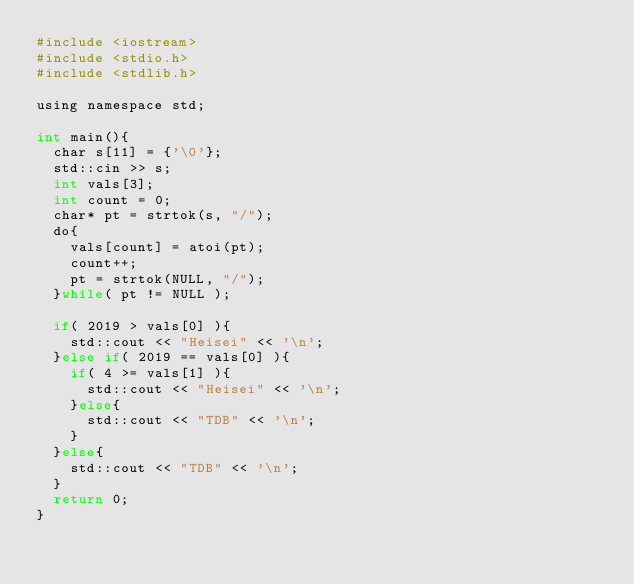<code> <loc_0><loc_0><loc_500><loc_500><_Python_>#include <iostream>
#include <stdio.h>
#include <stdlib.h>

using namespace std;

int main(){
  char s[11] = {'\0'};
  std::cin >> s;
  int vals[3];
  int count = 0;
  char* pt = strtok(s, "/");
  do{
    vals[count] = atoi(pt);
    count++;
    pt = strtok(NULL, "/");
  }while( pt != NULL );

  if( 2019 > vals[0] ){
    std::cout << "Heisei" << '\n';
  }else if( 2019 == vals[0] ){
    if( 4 >= vals[1] ){
      std::cout << "Heisei" << '\n';
    }else{
      std::cout << "TDB" << '\n';
    }
  }else{
    std::cout << "TDB" << '\n';
  }
  return 0;
}
</code> 